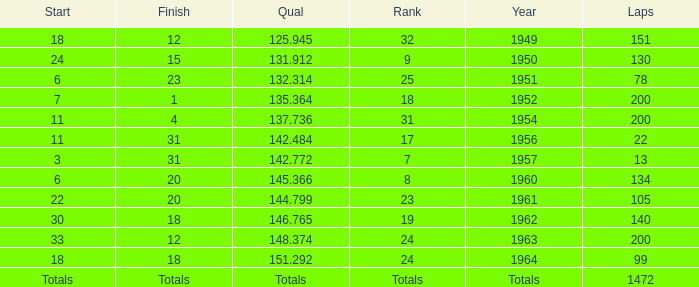Name the finish with Laps more than 200 Totals. 